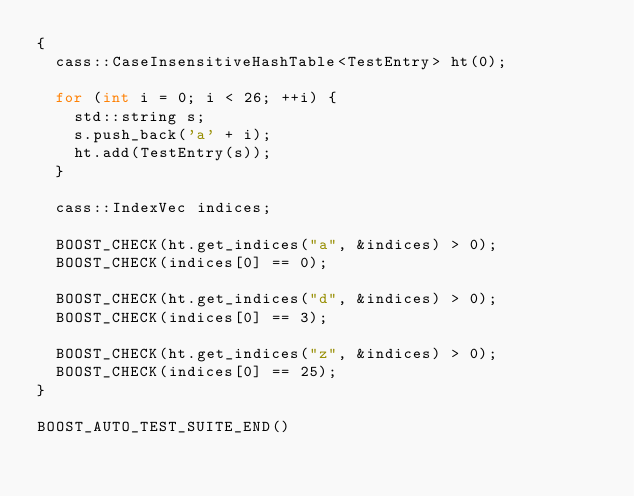<code> <loc_0><loc_0><loc_500><loc_500><_C++_>{
  cass::CaseInsensitiveHashTable<TestEntry> ht(0);

  for (int i = 0; i < 26; ++i) {
    std::string s;
    s.push_back('a' + i);
    ht.add(TestEntry(s));
  }

  cass::IndexVec indices;

  BOOST_CHECK(ht.get_indices("a", &indices) > 0);
  BOOST_CHECK(indices[0] == 0);

  BOOST_CHECK(ht.get_indices("d", &indices) > 0);
  BOOST_CHECK(indices[0] == 3);

  BOOST_CHECK(ht.get_indices("z", &indices) > 0);
  BOOST_CHECK(indices[0] == 25);
}

BOOST_AUTO_TEST_SUITE_END()


</code> 